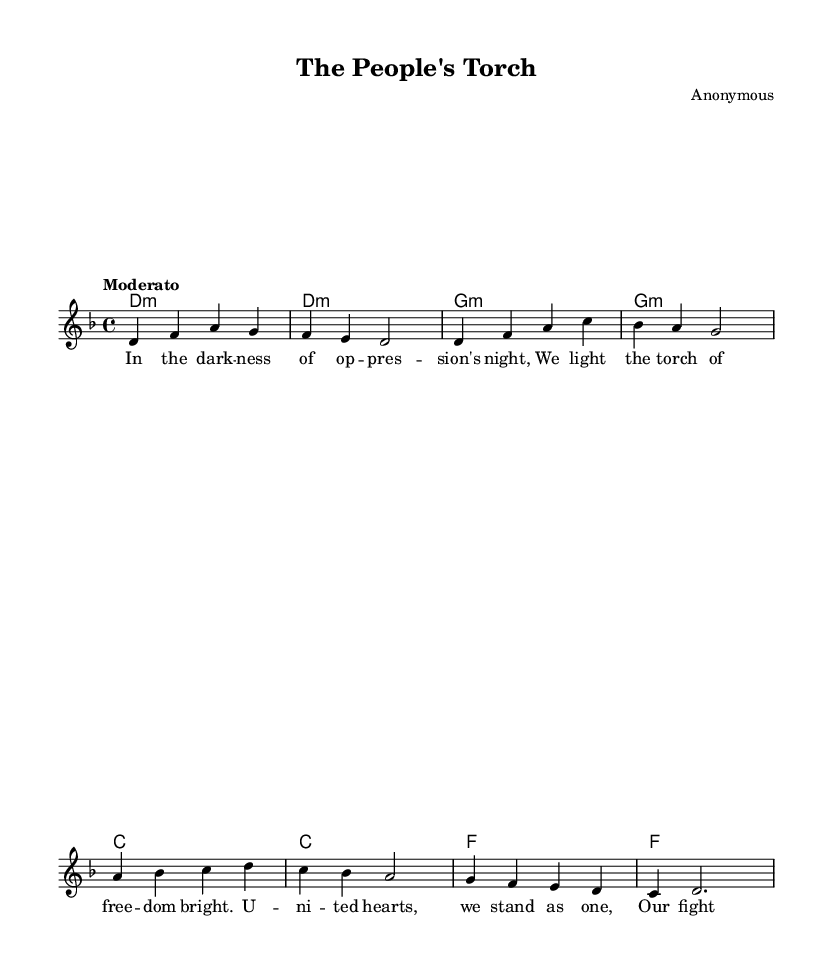What is the key signature of this music? The key signature is indicated at the beginning of the score, where there are no sharps or flats shown. This means the key is D minor, which contains one flat.
Answer: D minor What is the time signature of this music? The time signature appears at the beginning of the score and is written as 4/4, which means there are four beats per measure and the quarter note gets one beat.
Answer: 4/4 What is the tempo marking of this piece? The tempo marking is specified in Italian at the start of the piece as "Moderato," indicating a moderate tempo.
Answer: Moderato How many measures are in the melody section? By counting the distinct groups of notes separated by vertical bar lines in the melody, we find there are eight measures in total.
Answer: 8 Which instrument is primarily featured in this score? The score does not specify an instrument but presents the melody in a single staff, which suggests that it is written for a voice or a lead instrument within a band.
Answer: Voice What type of song is "The People's Torch"? The lyrics indicate a theme of unity and resistance against oppression, typical of revolutionary songs from resistance movements.
Answer: Revolutionary song What is the emotional tone conveyed through the lyrics? The words express hope and determination against oppression, characteristic of many songs associated with struggles for freedom and justice.
Answer: Hopeful 